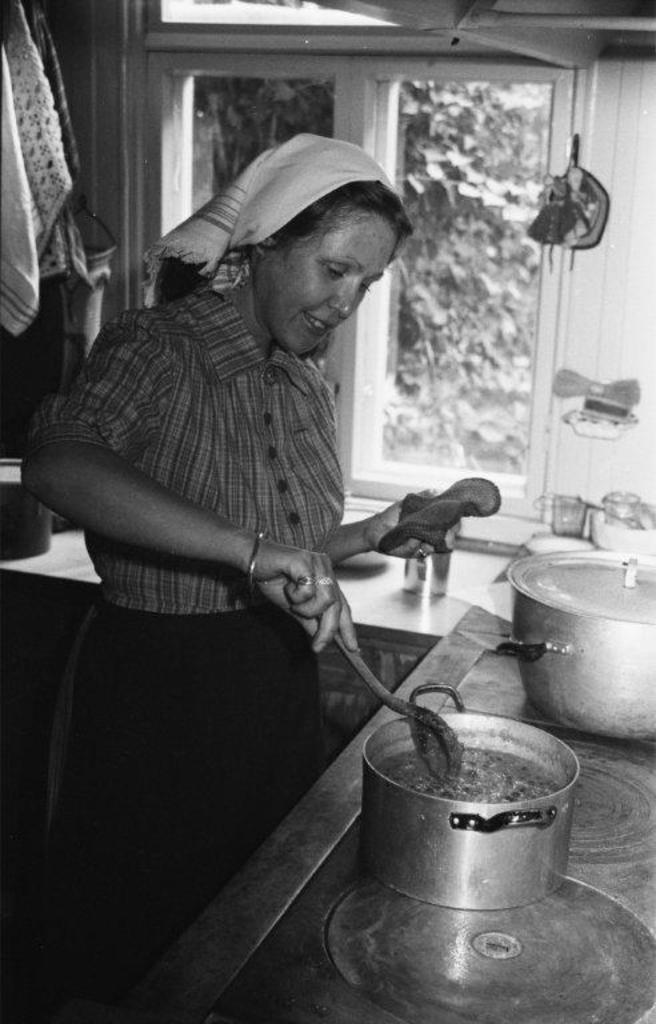Could you give a brief overview of what you see in this image? This is a black and white image. This picture is an inside view of a kitchen. In the center of the image we can see a lady is standing and holding a spoon. In the background of the image we can see a window, cloths, glass, vessels. Through window we can see a tree. 